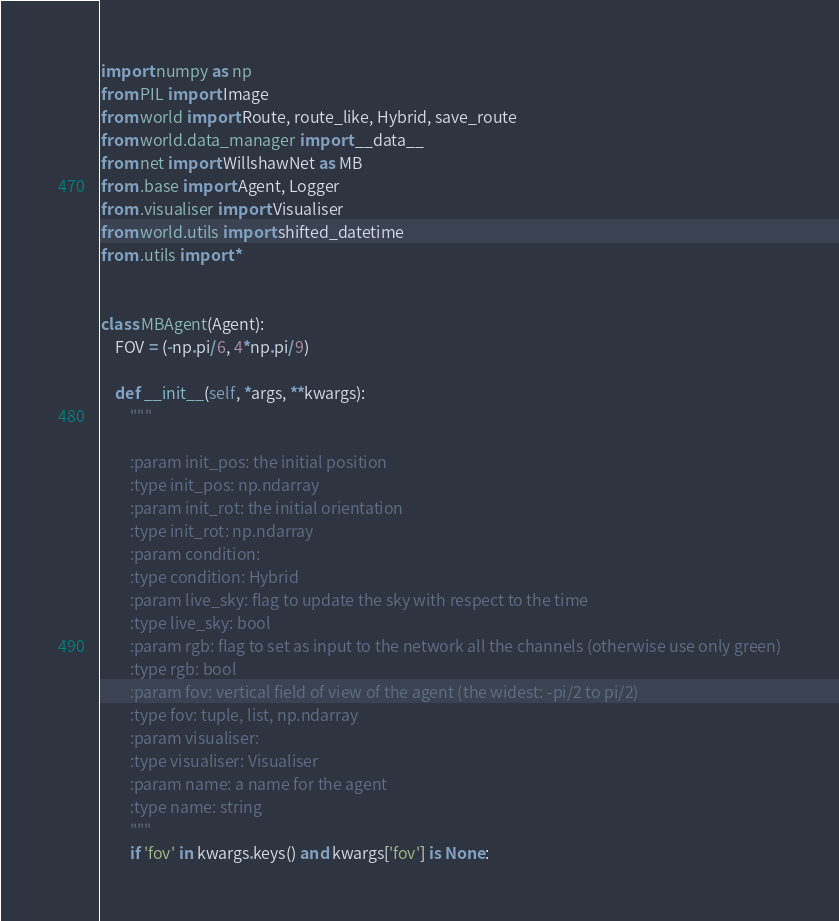Convert code to text. <code><loc_0><loc_0><loc_500><loc_500><_Python_>import numpy as np
from PIL import Image
from world import Route, route_like, Hybrid, save_route
from world.data_manager import __data__
from net import WillshawNet as MB
from .base import Agent, Logger
from .visualiser import Visualiser
from world.utils import shifted_datetime
from .utils import *


class MBAgent(Agent):
    FOV = (-np.pi/6, 4*np.pi/9)

    def __init__(self, *args, **kwargs):
        """

        :param init_pos: the initial position
        :type init_pos: np.ndarray
        :param init_rot: the initial orientation
        :type init_rot: np.ndarray
        :param condition:
        :type condition: Hybrid
        :param live_sky: flag to update the sky with respect to the time
        :type live_sky: bool
        :param rgb: flag to set as input to the network all the channels (otherwise use only green)
        :type rgb: bool
        :param fov: vertical field of view of the agent (the widest: -pi/2 to pi/2)
        :type fov: tuple, list, np.ndarray
        :param visualiser:
        :type visualiser: Visualiser
        :param name: a name for the agent
        :type name: string
        """
        if 'fov' in kwargs.keys() and kwargs['fov'] is None:</code> 